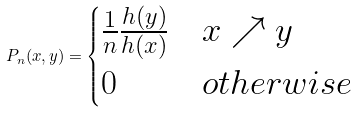<formula> <loc_0><loc_0><loc_500><loc_500>P _ { n } ( x , y ) = \begin{cases} \frac { 1 } { n } \frac { h ( y ) } { h ( x ) } & x \nearrow y \\ 0 & o t h e r w i s e \end{cases}</formula> 